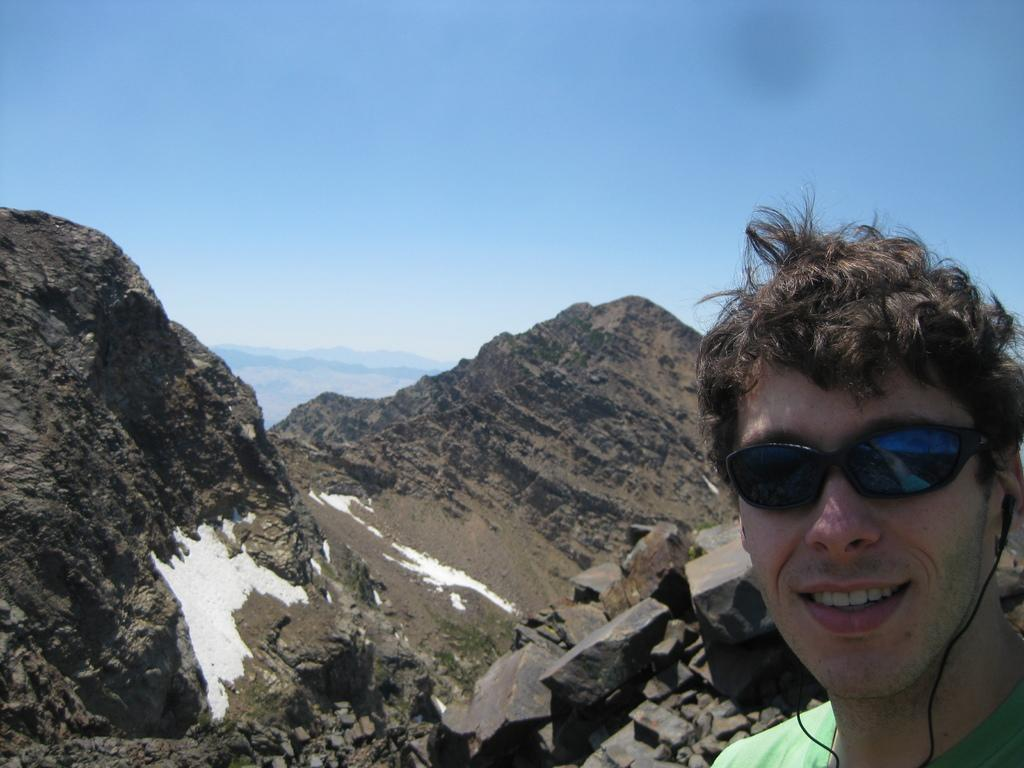What can be seen on the right side of the image? There is a person wearing spectacles on the right side of the image. What is visible in the background of the image? There are hills and rocks in the background of the image. What part of the natural environment is visible in the image? The sky is visible in the background of the image. What type of needle is being used to destroy the rocks in the image? There is no needle or destruction present in the image; it features a person wearing spectacles and a background with hills, rocks, and the sky. 